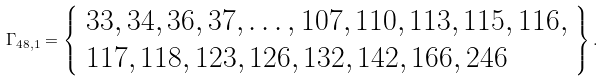<formula> <loc_0><loc_0><loc_500><loc_500>\Gamma _ { 4 8 , 1 } = \left \{ \begin{array} { l } 3 3 , 3 4 , 3 6 , 3 7 , \dots , 1 0 7 , 1 1 0 , 1 1 3 , 1 1 5 , 1 1 6 , \\ 1 1 7 , 1 1 8 , 1 2 3 , 1 2 6 , 1 3 2 , 1 4 2 , 1 6 6 , 2 4 6 \end{array} \right \} .</formula> 